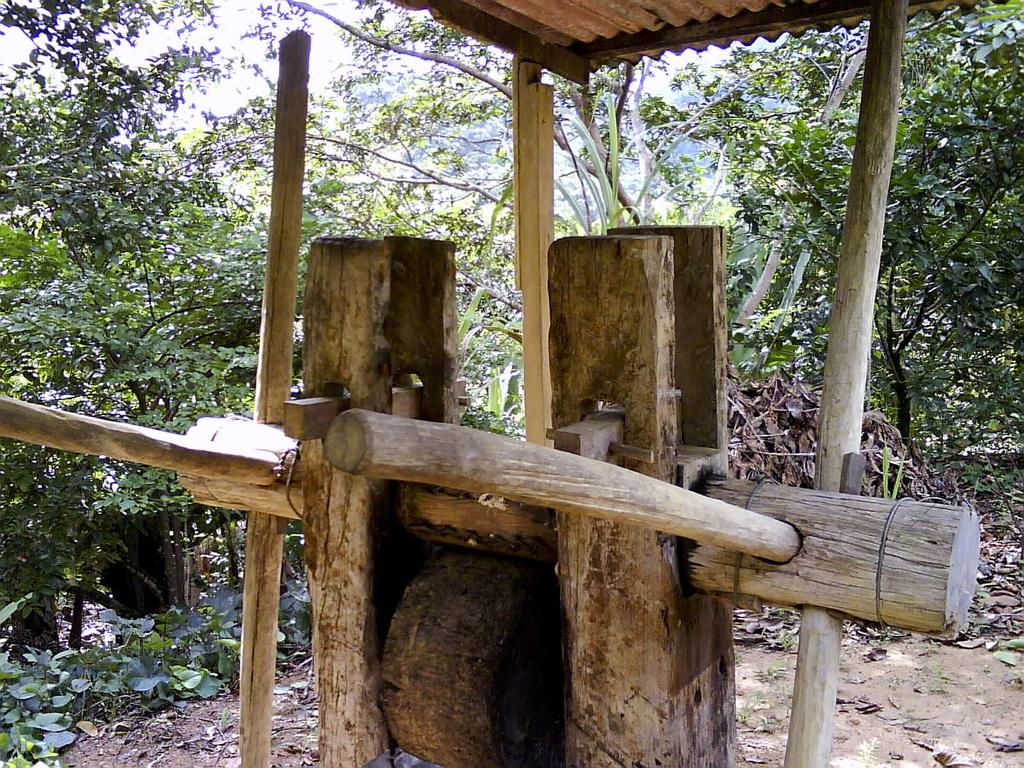What type of objects can be seen in the image? There are wooden poles in the image. What natural elements are visible in the image? Trees are visible in the image. What can be found on the ground in the image? Leaves are present on the ground in the image. What type of rhythm can be heard coming from the table in the image? There is no table present in the image, and therefore no rhythm can be heard. 